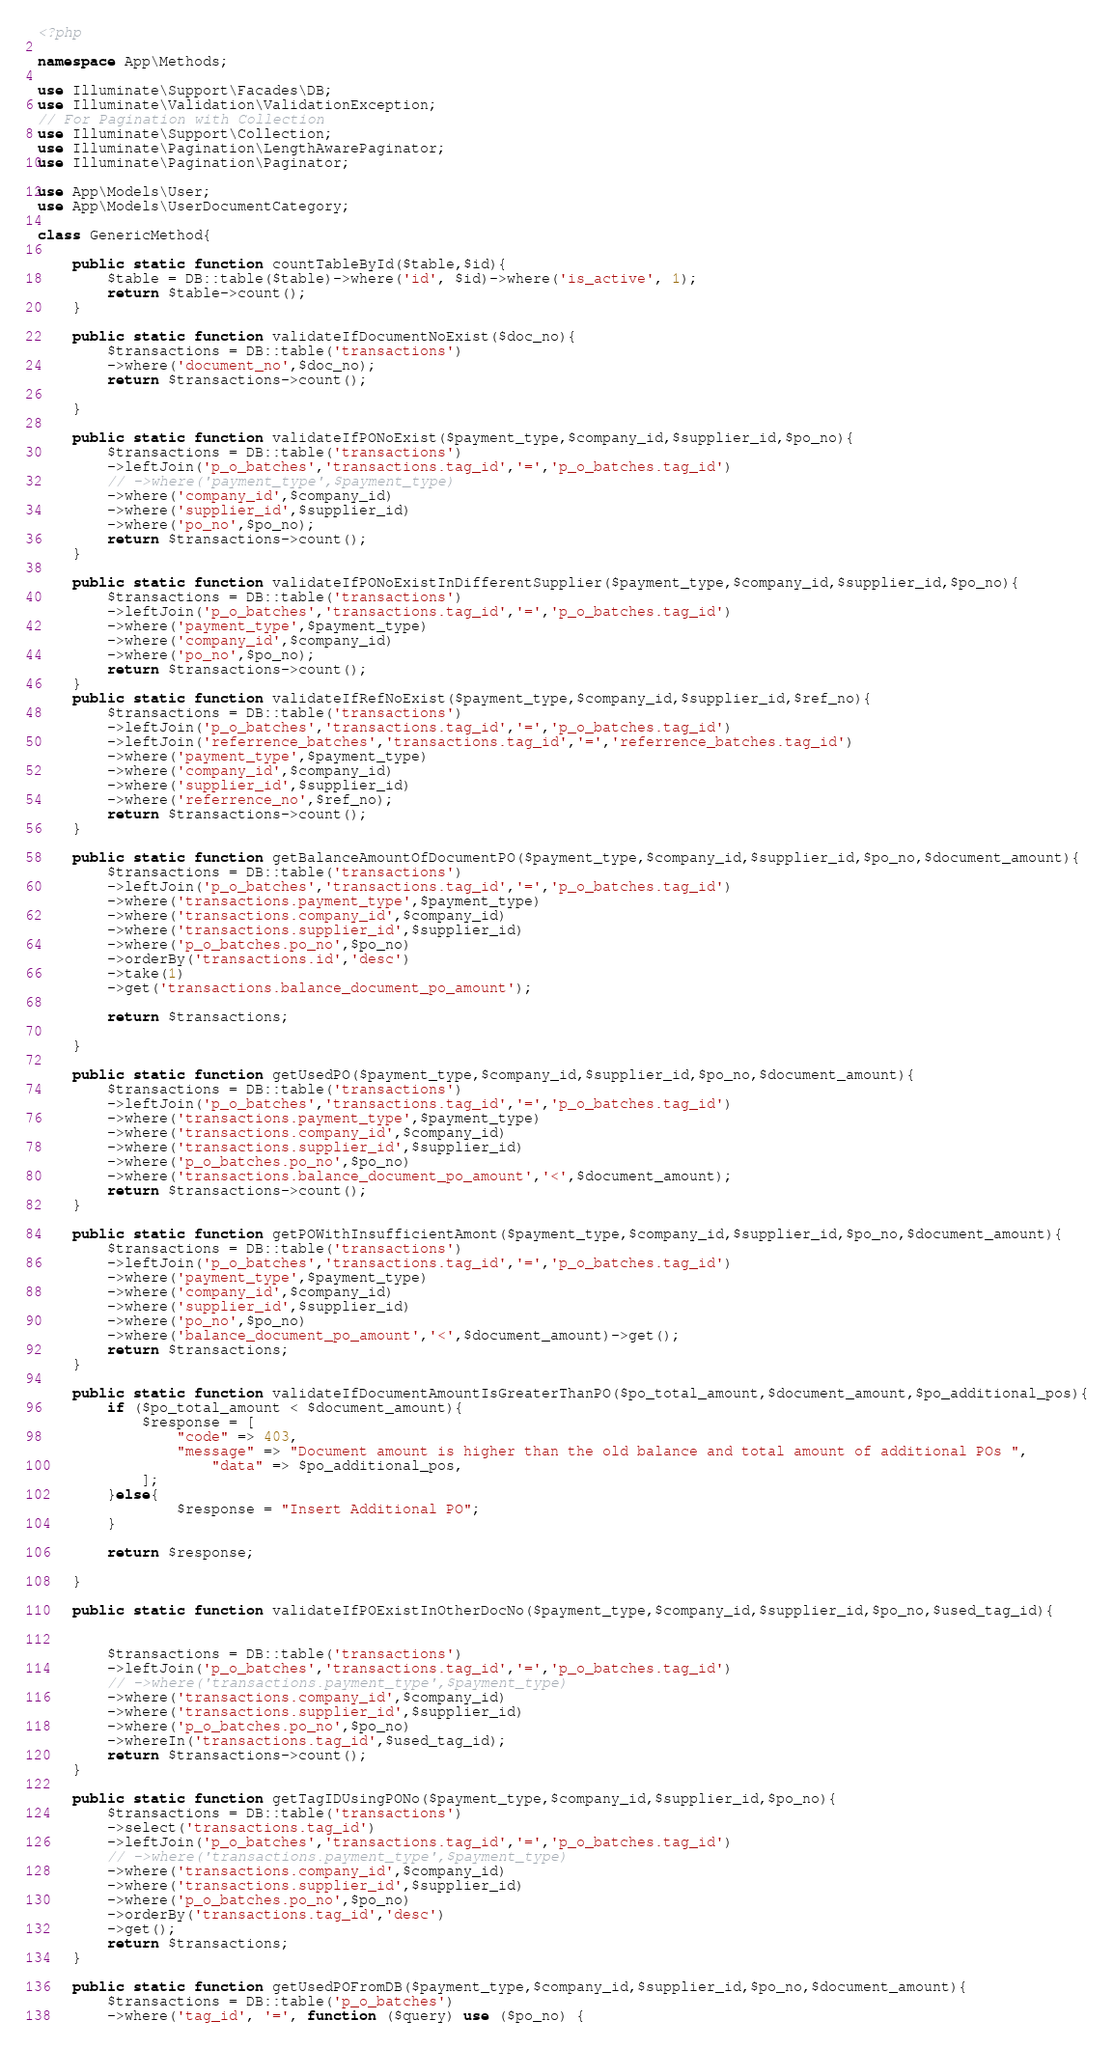Convert code to text. <code><loc_0><loc_0><loc_500><loc_500><_PHP_><?php

namespace App\Methods;

use Illuminate\Support\Facades\DB;
use Illuminate\Validation\ValidationException;
// For Pagination with Collection
use Illuminate\Support\Collection;
use Illuminate\Pagination\LengthAwarePaginator;
use Illuminate\Pagination\Paginator;

use App\Models\User;
use App\Models\UserDocumentCategory;

class GenericMethod{

    public static function countTableById($table,$id){
        $table = DB::table($table)->where('id', $id)->where('is_active', 1);
        return $table->count();
    }

    public static function validateIfDocumentNoExist($doc_no){
        $transactions = DB::table('transactions')
        ->where('document_no',$doc_no);
        return $transactions->count();

    }

    public static function validateIfPONoExist($payment_type,$company_id,$supplier_id,$po_no){
        $transactions = DB::table('transactions')
        ->leftJoin('p_o_batches','transactions.tag_id','=','p_o_batches.tag_id')
        // ->where('payment_type',$payment_type)
        ->where('company_id',$company_id)
        ->where('supplier_id',$supplier_id)
        ->where('po_no',$po_no);
        return $transactions->count();
    }

    public static function validateIfPONoExistInDifferentSupplier($payment_type,$company_id,$supplier_id,$po_no){
        $transactions = DB::table('transactions')
        ->leftJoin('p_o_batches','transactions.tag_id','=','p_o_batches.tag_id')
        ->where('payment_type',$payment_type)
        ->where('company_id',$company_id)
        ->where('po_no',$po_no);
        return $transactions->count();
    }
    public static function validateIfRefNoExist($payment_type,$company_id,$supplier_id,$ref_no){
        $transactions = DB::table('transactions')
        ->leftJoin('p_o_batches','transactions.tag_id','=','p_o_batches.tag_id')
        ->leftJoin('referrence_batches','transactions.tag_id','=','referrence_batches.tag_id')
        ->where('payment_type',$payment_type)
        ->where('company_id',$company_id)
        ->where('supplier_id',$supplier_id)
        ->where('referrence_no',$ref_no);
        return $transactions->count();
    }

    public static function getBalanceAmountOfDocumentPO($payment_type,$company_id,$supplier_id,$po_no,$document_amount){
        $transactions = DB::table('transactions')
        ->leftJoin('p_o_batches','transactions.tag_id','=','p_o_batches.tag_id')
        ->where('transactions.payment_type',$payment_type)
        ->where('transactions.company_id',$company_id)
        ->where('transactions.supplier_id',$supplier_id)
        ->where('p_o_batches.po_no',$po_no)
        ->orderBy('transactions.id','desc')
        ->take(1)
        ->get('transactions.balance_document_po_amount');

        return $transactions;

    }

    public static function getUsedPO($payment_type,$company_id,$supplier_id,$po_no,$document_amount){
        $transactions = DB::table('transactions')
        ->leftJoin('p_o_batches','transactions.tag_id','=','p_o_batches.tag_id')
        ->where('transactions.payment_type',$payment_type)
        ->where('transactions.company_id',$company_id)
        ->where('transactions.supplier_id',$supplier_id)
        ->where('p_o_batches.po_no',$po_no)
        ->where('transactions.balance_document_po_amount','<',$document_amount);
        return $transactions->count();
    }

    public static function getPOWithInsufficientAmont($payment_type,$company_id,$supplier_id,$po_no,$document_amount){
        $transactions = DB::table('transactions')
        ->leftJoin('p_o_batches','transactions.tag_id','=','p_o_batches.tag_id')
        ->where('payment_type',$payment_type)
        ->where('company_id',$company_id)
        ->where('supplier_id',$supplier_id)
        ->where('po_no',$po_no)
        ->where('balance_document_po_amount','<',$document_amount)->get();
        return $transactions;
    }

    public static function validateIfDocumentAmountIsGreaterThanPO($po_total_amount,$document_amount,$po_additional_pos){
        if ($po_total_amount < $document_amount){
            $response = [
                "code" => 403,
                "message" => "Document amount is higher than the old balance and total amount of additional POs ",
                    "data" => $po_additional_pos,
            ];
        }else{
                $response = "Insert Additional PO";
        }

        return $response;

    }

    public static function validateIfPOExistInOtherDocNo($payment_type,$company_id,$supplier_id,$po_no,$used_tag_id){


        $transactions = DB::table('transactions')
        ->leftJoin('p_o_batches','transactions.tag_id','=','p_o_batches.tag_id')
        // ->where('transactions.payment_type',$payment_type)
        ->where('transactions.company_id',$company_id)
        ->where('transactions.supplier_id',$supplier_id)
        ->where('p_o_batches.po_no',$po_no)
        ->whereIn('transactions.tag_id',$used_tag_id);
        return $transactions->count();
    }

    public static function getTagIDUsingPONo($payment_type,$company_id,$supplier_id,$po_no){
        $transactions = DB::table('transactions')
        ->select('transactions.tag_id')
        ->leftJoin('p_o_batches','transactions.tag_id','=','p_o_batches.tag_id')
        // ->where('transactions.payment_type',$payment_type)
        ->where('transactions.company_id',$company_id)
        ->where('transactions.supplier_id',$supplier_id)
        ->where('p_o_batches.po_no',$po_no)
        ->orderBy('transactions.tag_id','desc')
        ->get();
        return $transactions;
    }

    public static function getUsedPOFromDB($payment_type,$company_id,$supplier_id,$po_no,$document_amount){
        $transactions = DB::table('p_o_batches')
        ->where('tag_id', '=', function ($query) use ($po_no) {</code> 